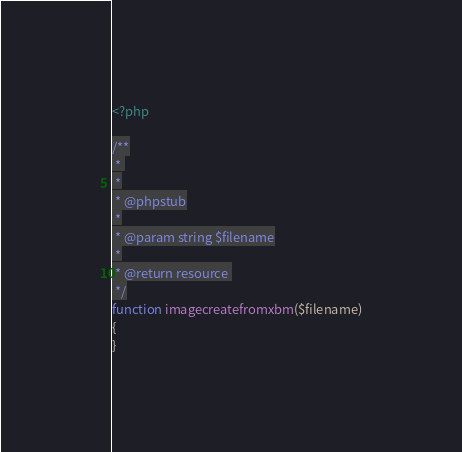<code> <loc_0><loc_0><loc_500><loc_500><_PHP_><?php

/**
 * 
 *
 * @phpstub
 *
 * @param string $filename
 *
 * @return resource 
 */
function imagecreatefromxbm($filename)
{
}</code> 